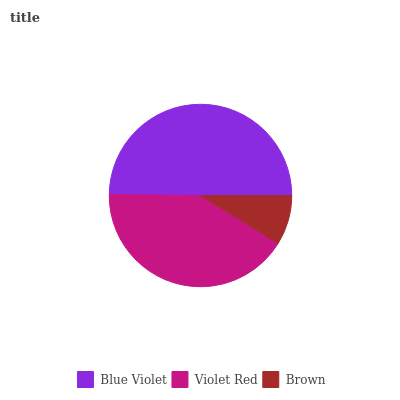Is Brown the minimum?
Answer yes or no. Yes. Is Blue Violet the maximum?
Answer yes or no. Yes. Is Violet Red the minimum?
Answer yes or no. No. Is Violet Red the maximum?
Answer yes or no. No. Is Blue Violet greater than Violet Red?
Answer yes or no. Yes. Is Violet Red less than Blue Violet?
Answer yes or no. Yes. Is Violet Red greater than Blue Violet?
Answer yes or no. No. Is Blue Violet less than Violet Red?
Answer yes or no. No. Is Violet Red the high median?
Answer yes or no. Yes. Is Violet Red the low median?
Answer yes or no. Yes. Is Brown the high median?
Answer yes or no. No. Is Blue Violet the low median?
Answer yes or no. No. 